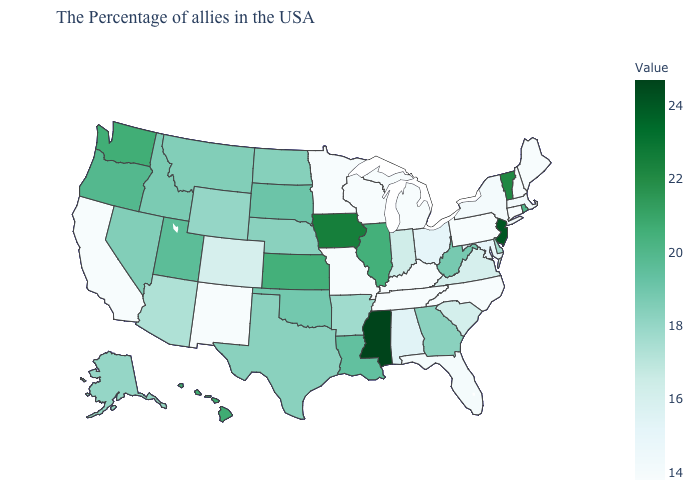Which states have the lowest value in the USA?
Concise answer only. Maine, New Hampshire, Connecticut, Pennsylvania, North Carolina, Michigan, Kentucky, Tennessee, Wisconsin, Missouri, Minnesota, New Mexico, California. Which states have the highest value in the USA?
Keep it brief. Mississippi. Among the states that border Iowa , which have the highest value?
Quick response, please. Illinois. 